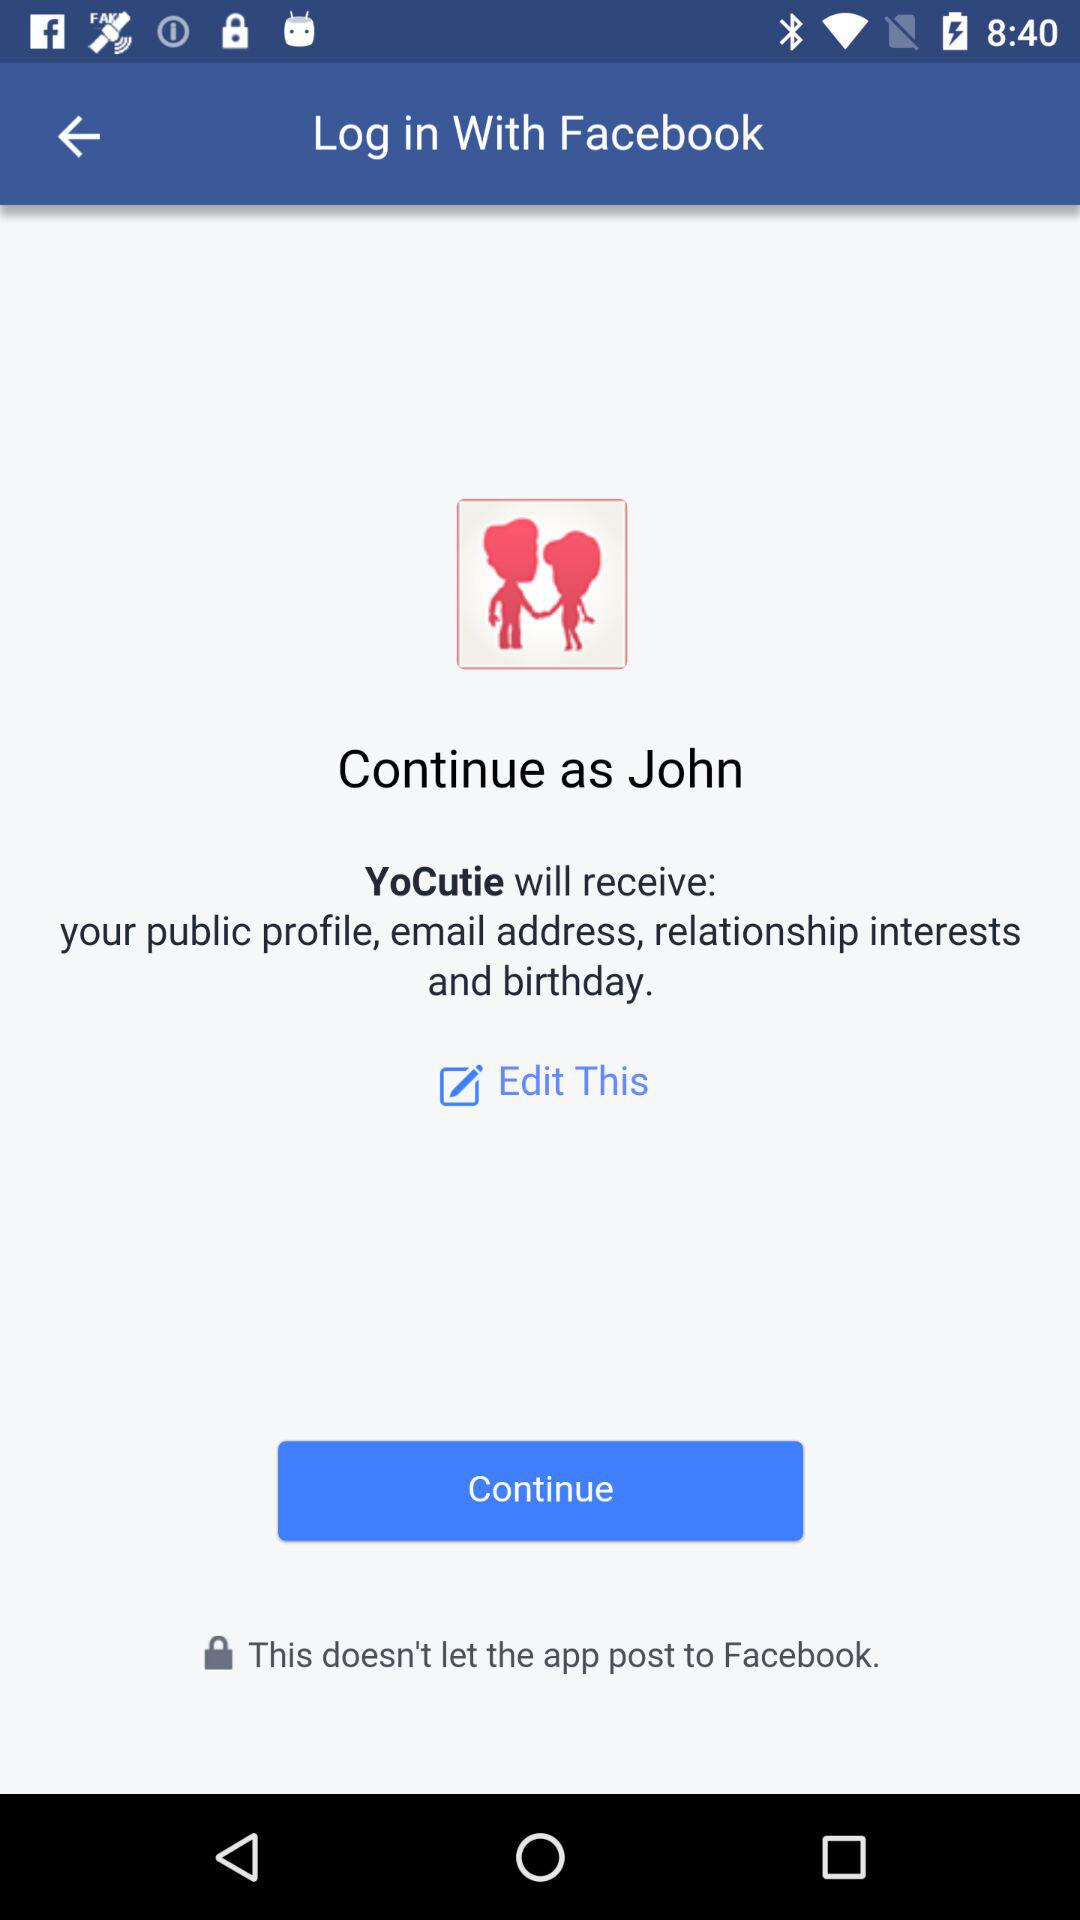What is the user name? The user name is John. 